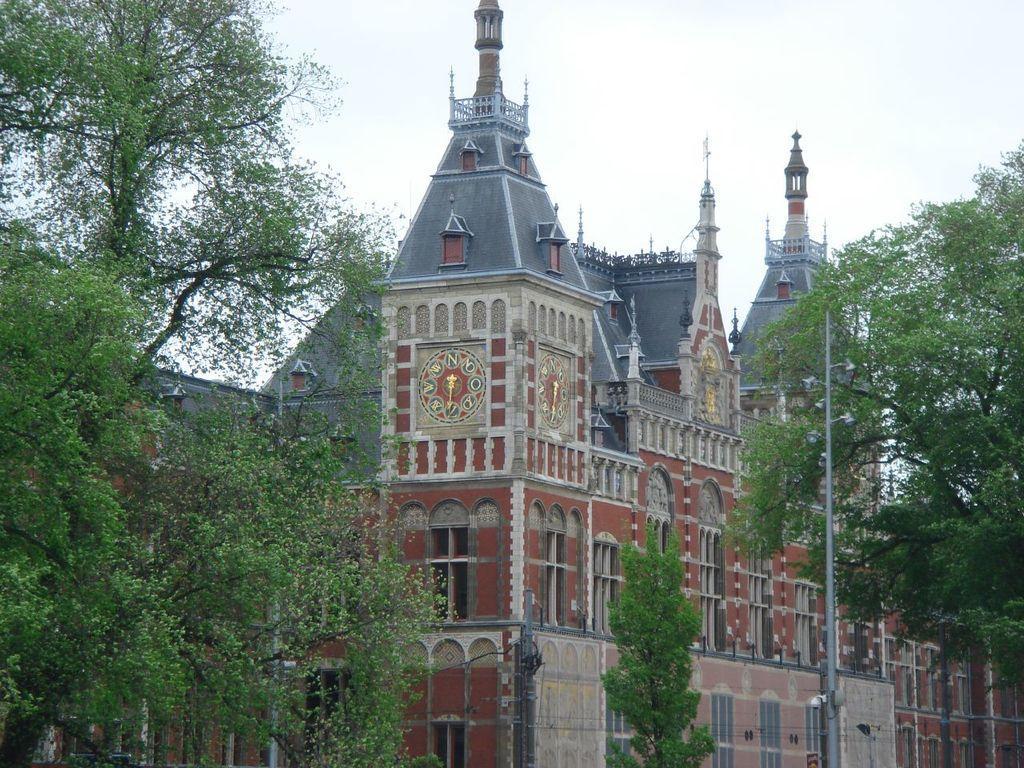Can you describe this image briefly? In this picture there is a building and there are trees on either sides of it and there is a pole in the right corner. 